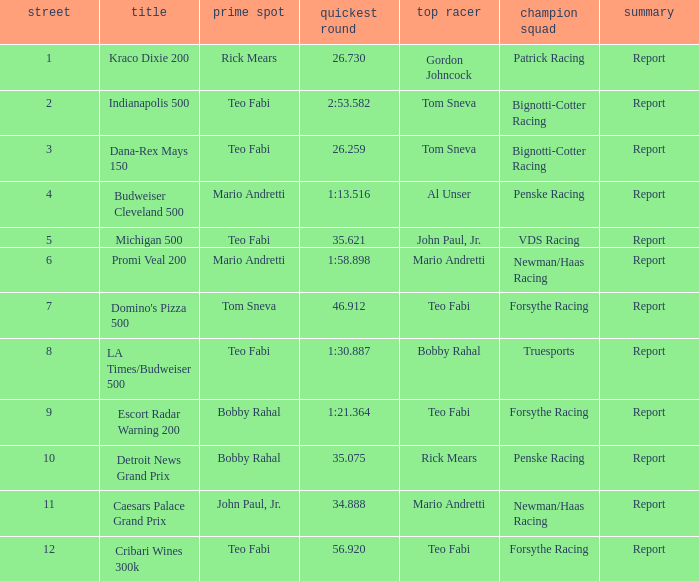Which teams won when Bobby Rahal was their winning driver? Truesports. Would you be able to parse every entry in this table? {'header': ['street', 'title', 'prime spot', 'quickest round', 'top racer', 'champion squad', 'summary'], 'rows': [['1', 'Kraco Dixie 200', 'Rick Mears', '26.730', 'Gordon Johncock', 'Patrick Racing', 'Report'], ['2', 'Indianapolis 500', 'Teo Fabi', '2:53.582', 'Tom Sneva', 'Bignotti-Cotter Racing', 'Report'], ['3', 'Dana-Rex Mays 150', 'Teo Fabi', '26.259', 'Tom Sneva', 'Bignotti-Cotter Racing', 'Report'], ['4', 'Budweiser Cleveland 500', 'Mario Andretti', '1:13.516', 'Al Unser', 'Penske Racing', 'Report'], ['5', 'Michigan 500', 'Teo Fabi', '35.621', 'John Paul, Jr.', 'VDS Racing', 'Report'], ['6', 'Promi Veal 200', 'Mario Andretti', '1:58.898', 'Mario Andretti', 'Newman/Haas Racing', 'Report'], ['7', "Domino's Pizza 500", 'Tom Sneva', '46.912', 'Teo Fabi', 'Forsythe Racing', 'Report'], ['8', 'LA Times/Budweiser 500', 'Teo Fabi', '1:30.887', 'Bobby Rahal', 'Truesports', 'Report'], ['9', 'Escort Radar Warning 200', 'Bobby Rahal', '1:21.364', 'Teo Fabi', 'Forsythe Racing', 'Report'], ['10', 'Detroit News Grand Prix', 'Bobby Rahal', '35.075', 'Rick Mears', 'Penske Racing', 'Report'], ['11', 'Caesars Palace Grand Prix', 'John Paul, Jr.', '34.888', 'Mario Andretti', 'Newman/Haas Racing', 'Report'], ['12', 'Cribari Wines 300k', 'Teo Fabi', '56.920', 'Teo Fabi', 'Forsythe Racing', 'Report']]} 